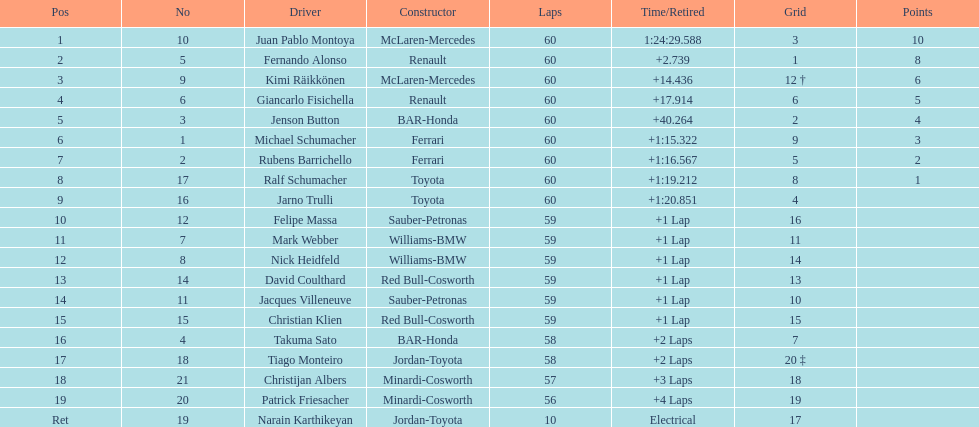Is there a points difference between the 9th position and 19th position on the list? No. 